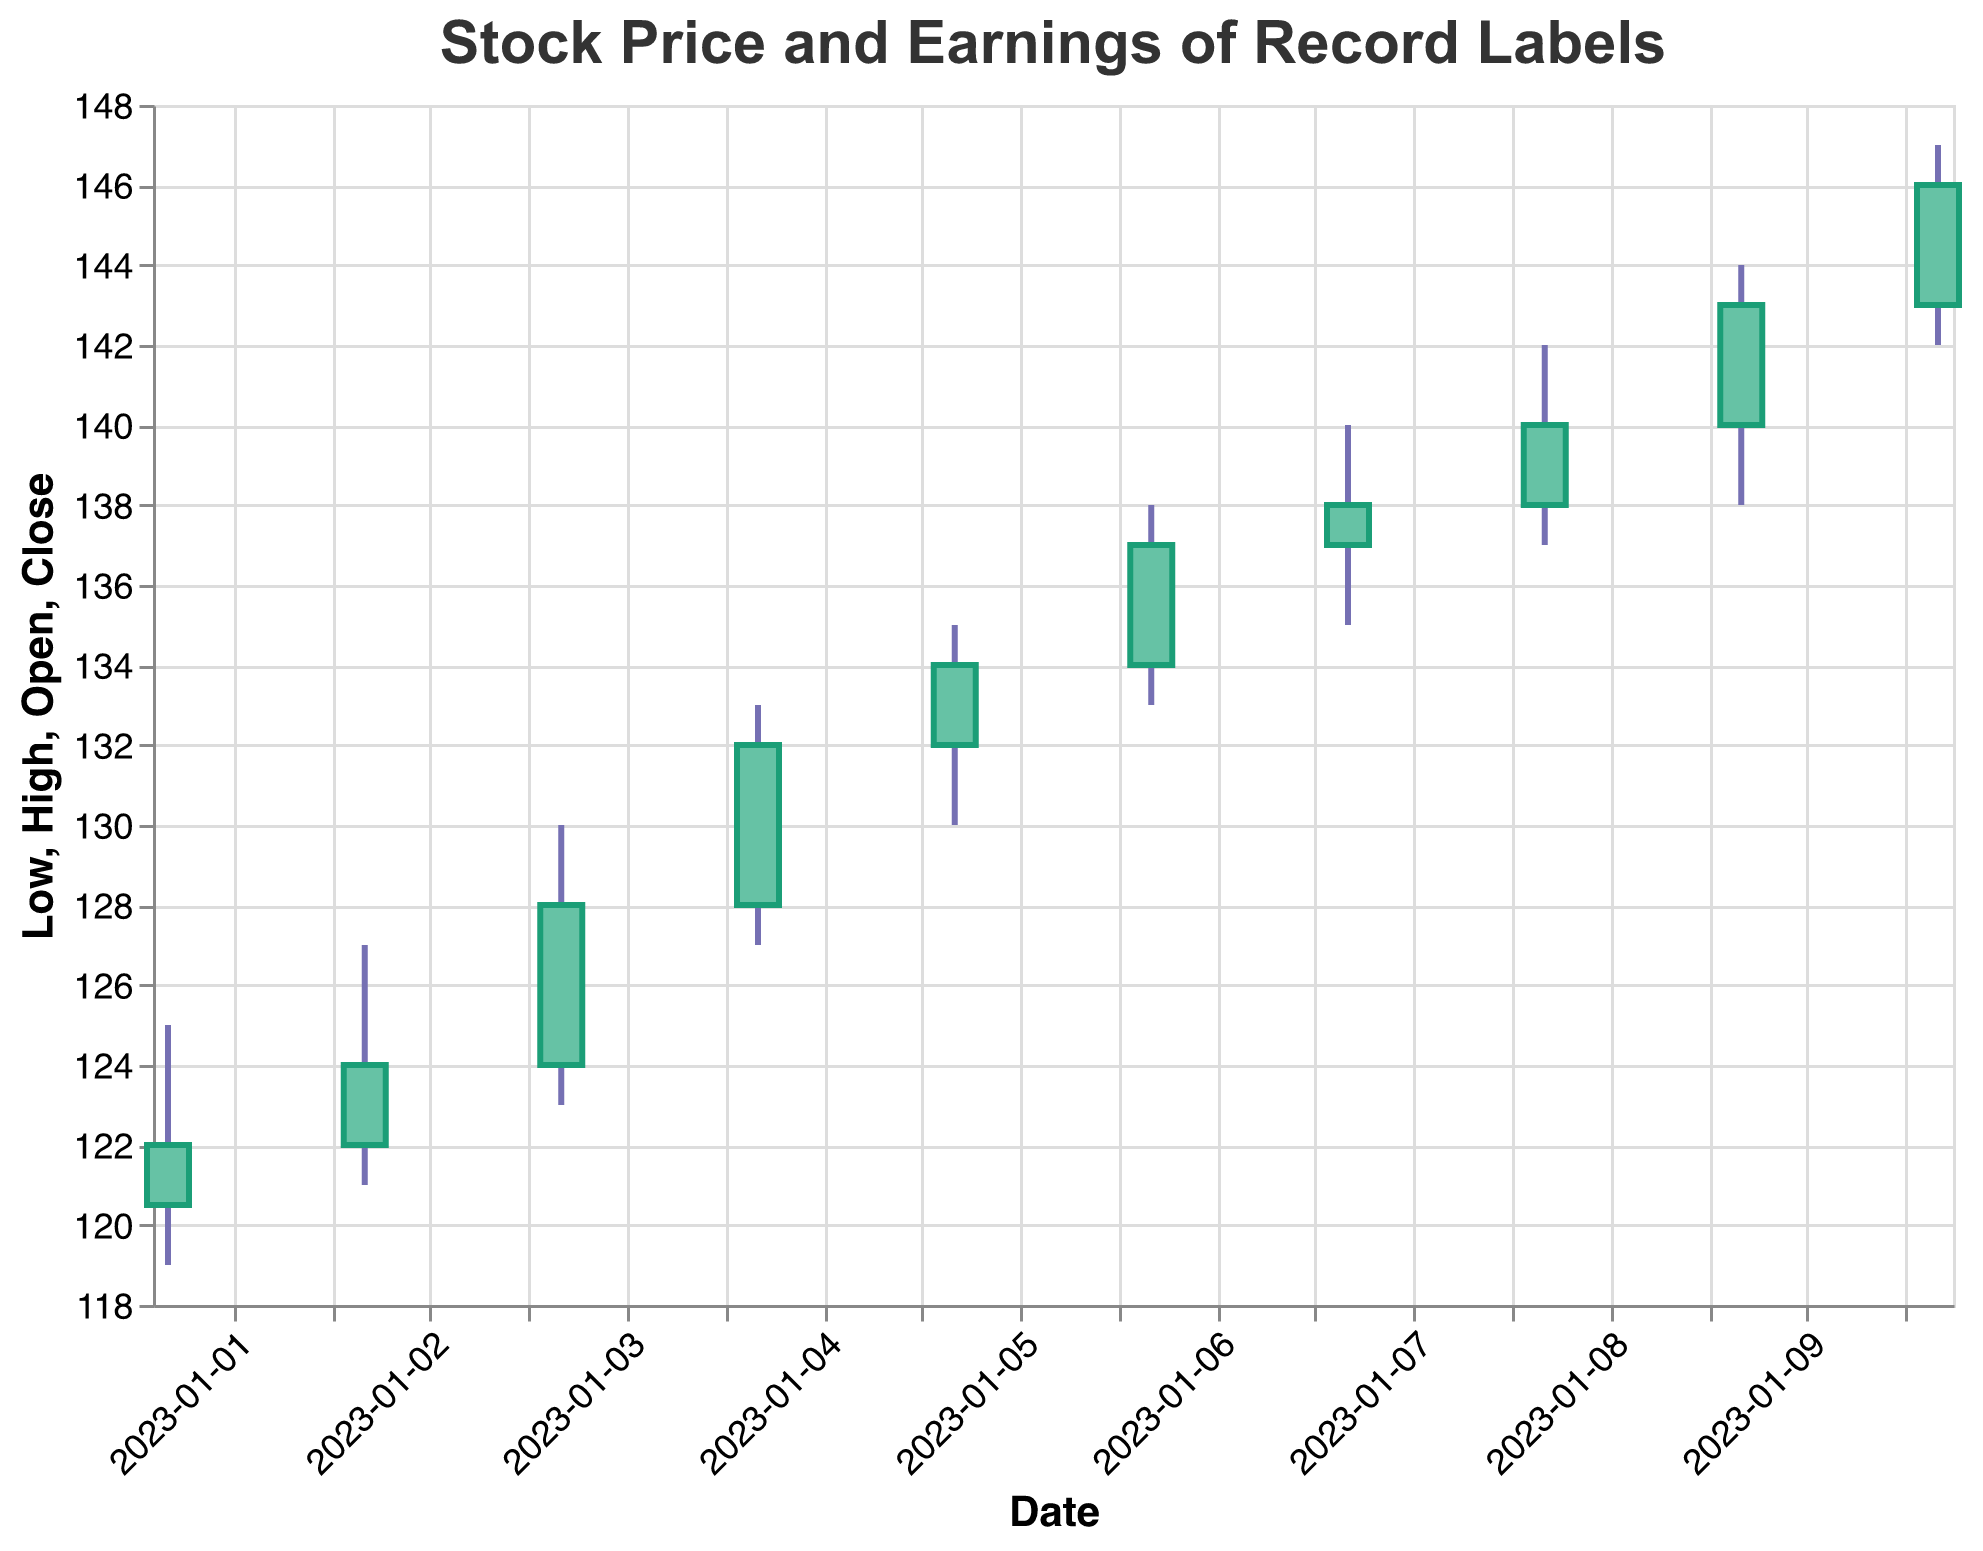What is the title of the figure? The title is usually displayed at the top of the figure. In this instance, it reads "Stock Price and Earnings of Record Labels".
Answer: Stock Price and Earnings of Record Labels What are the axes labels in the figure? The x-axis represents the date, labeled as "Date," and the y-axis represents the price, labeled as "Price".
Answer: Date, Price How many days are displayed in the figure? Each candlestick represents one day of stock data, from January 1, 2023 to January 10, 2023. Counting these dates gives 10 days.
Answer: 10 Which day had the highest closing price and what was it? Look for the highest point of the closing prices on the candlesticks. January 10 has the highest closing price at $146.00.
Answer: January 10, $146.00 Which record label had the highest earnings and what was the corresponding top-charting single? The highest earnings are $15,000,000, on January 10. The record label is Universal Music Group, and the top-charting single is "Watermelon Sugar".
Answer: Universal Music Group, Watermelon Sugar On which dates did Universal Music Group have top-charting singles? Look for the entries where the "Record_Label" is "Universal Music Group": January 1, 4, 7, and 10.
Answer: January 1, 4, 7, 10 How did the stock price on January 3 compare to January 2? Did it go up or down, and by how much? The closing price on January 2 was $124.00 and on January 3 it was $128.00. The stock price went up by $4.00 ($128.00 - $124.00).
Answer: Up by $4.00 What is the average volume traded per day over the period covered in the figure? Sum the values of "Volume" for each day, then divide by the number of days. The volumes sum to 39,200,000 and dividing by 10 days gives an average of 3,920,000.
Answer: 3,920,000 Between Sony Music Entertainment and Warner Music Group, which record label had higher earnings on January 6? Compare earnings on January 6 where "Record_Label" is "Sony Music Entertainment" and "Warner Music Group". Warner Music Group had higher earnings at $13,000,000.
Answer: Warner Music Group What pattern do you observe between earnings and stock prices? Higher earnings generally correspond to higher stock closing prices. For example, earnings on January 10 were $15,000,000, and the stock closed at the highest price of $146.00.
Answer: Higher earnings correspond to higher stock prices 